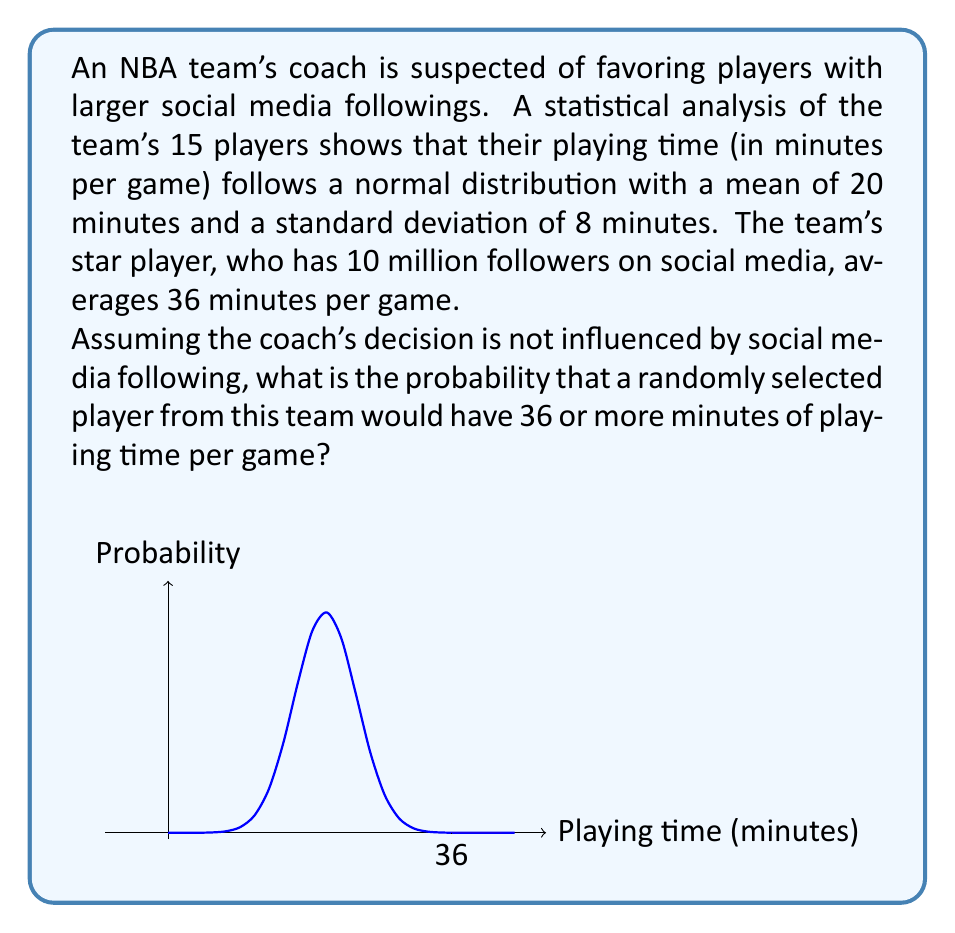Could you help me with this problem? To solve this problem, we'll use the properties of the normal distribution and the concept of z-scores. Let's break it down step-by-step:

1) We're given that the playing time follows a normal distribution with:
   Mean (μ) = 20 minutes
   Standard deviation (σ) = 8 minutes

2) We want to find the probability of a player having 36 or more minutes of playing time.

3) First, we need to calculate the z-score for 36 minutes:

   $$z = \frac{x - μ}{σ} = \frac{36 - 20}{8} = 2$$

4) This z-score of 2 means that 36 minutes is 2 standard deviations above the mean.

5) Now, we need to find the area under the standard normal curve to the right of z = 2.

6) Using a standard normal table or a calculator, we can find that:

   $$P(Z > 2) ≈ 0.0228$$

7) This means that approximately 2.28% of the area under the normal curve is to the right of z = 2.

8) Therefore, if the coach's decision is not influenced by social media following, there's about a 2.28% chance that a randomly selected player would have 36 or more minutes of playing time per game.

This low probability suggests that it's quite unusual for a player to get this much playing time, which might support the suspicion that factors other than pure chance (such as social media following) could be influencing the coach's decisions.
Answer: 0.0228 or 2.28% 